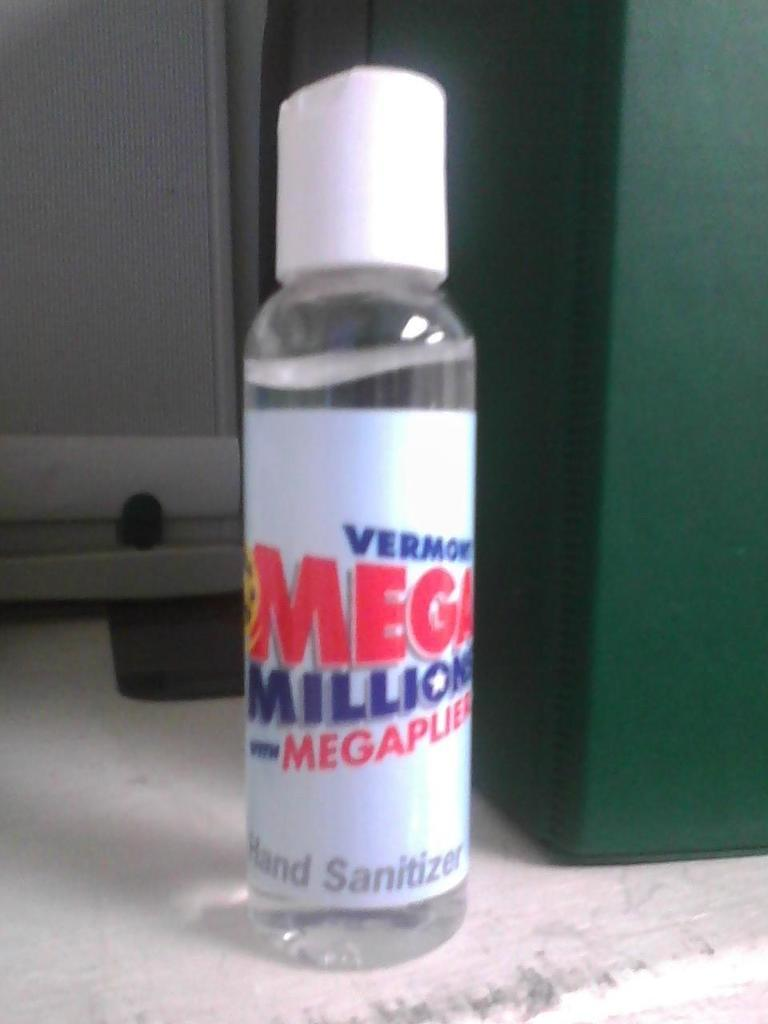<image>
Describe the image concisely. a small clear bottle of Hand Sanitizer for Vermont Mega Millions 